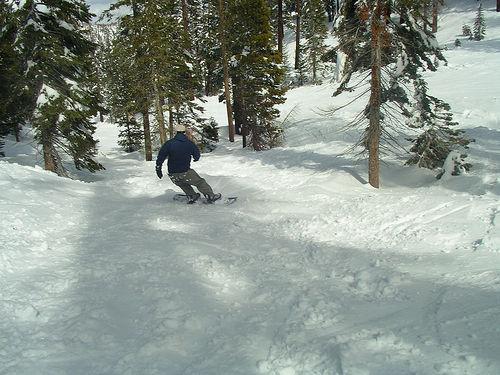What kind of trees can be seen in the snowy hill at the scene? Pine trees can be seen in the snowy hill. Mention two clothing items that the man in the image is wearing and their colors. The man is wearing a blue jacket and gray pants. What is the man in the picture wearing on his head? The man in the picture is wearing a white hat. Identify the primary activity happening in the image. A man snowboarding on a snow-covered hill surrounded by trees. State an observation about the snowboard in the image. The snowboard is white. Name the object that the man in the image is standing on. The man is standing on a snowboard. What color is the jacket that the man is wearing? The man is wearing a blue jacket. If this image were to be used for a product advertisement, what would the product most likely be? The product being advertised would most likely be a snowboard or snowboarding gear. Describe the general environment of the scene in the image. A snowy area with trees and snow all over the ground. Name one prominent element in the image that is not related to the snowboarder. A pine tree in the snowy area. 